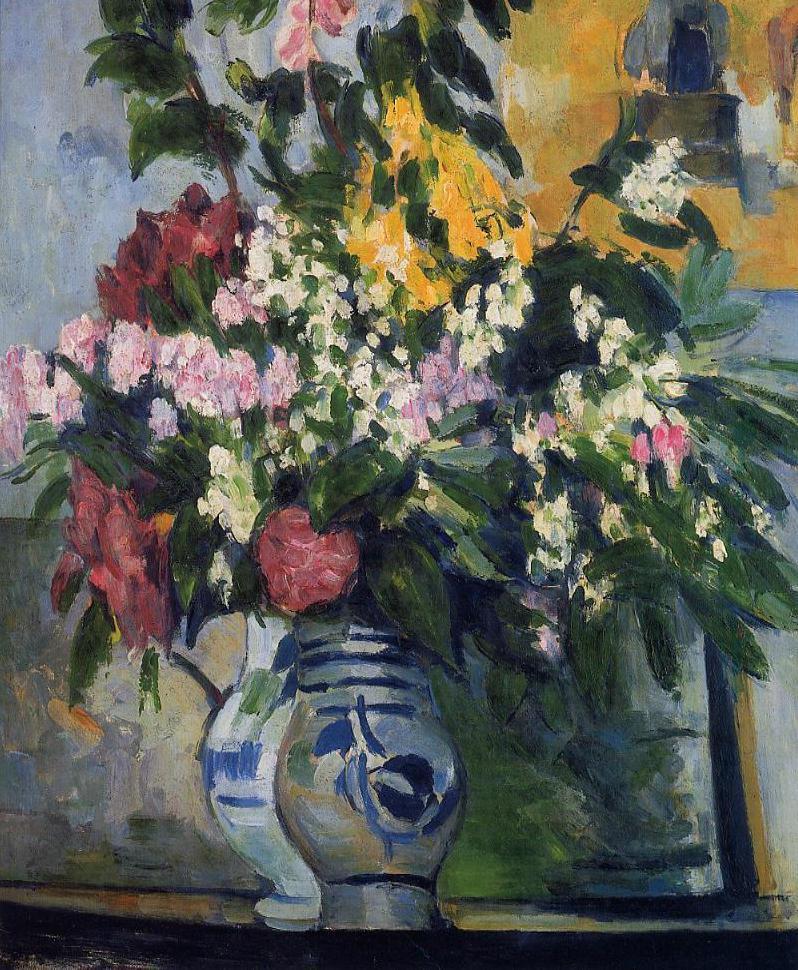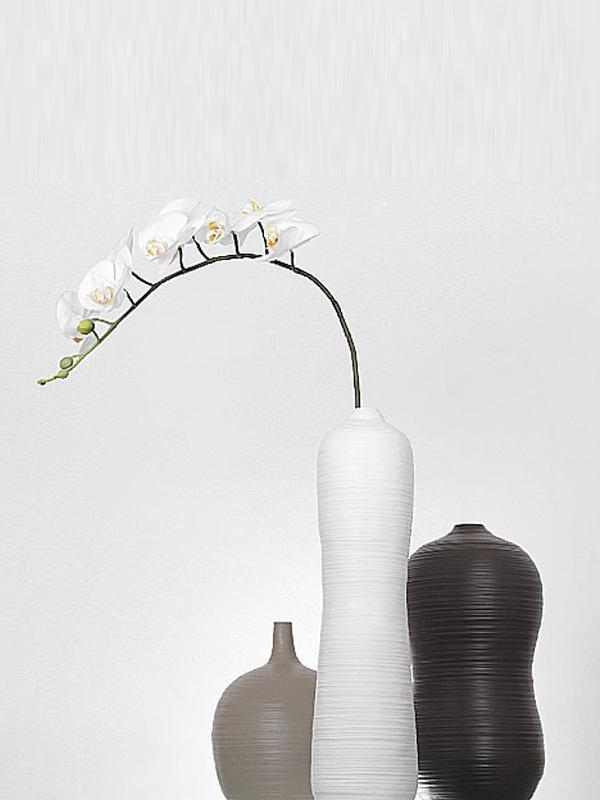The first image is the image on the left, the second image is the image on the right. Assess this claim about the two images: "In one of the image there is a black vase with a flower sticking out.". Correct or not? Answer yes or no. No. 